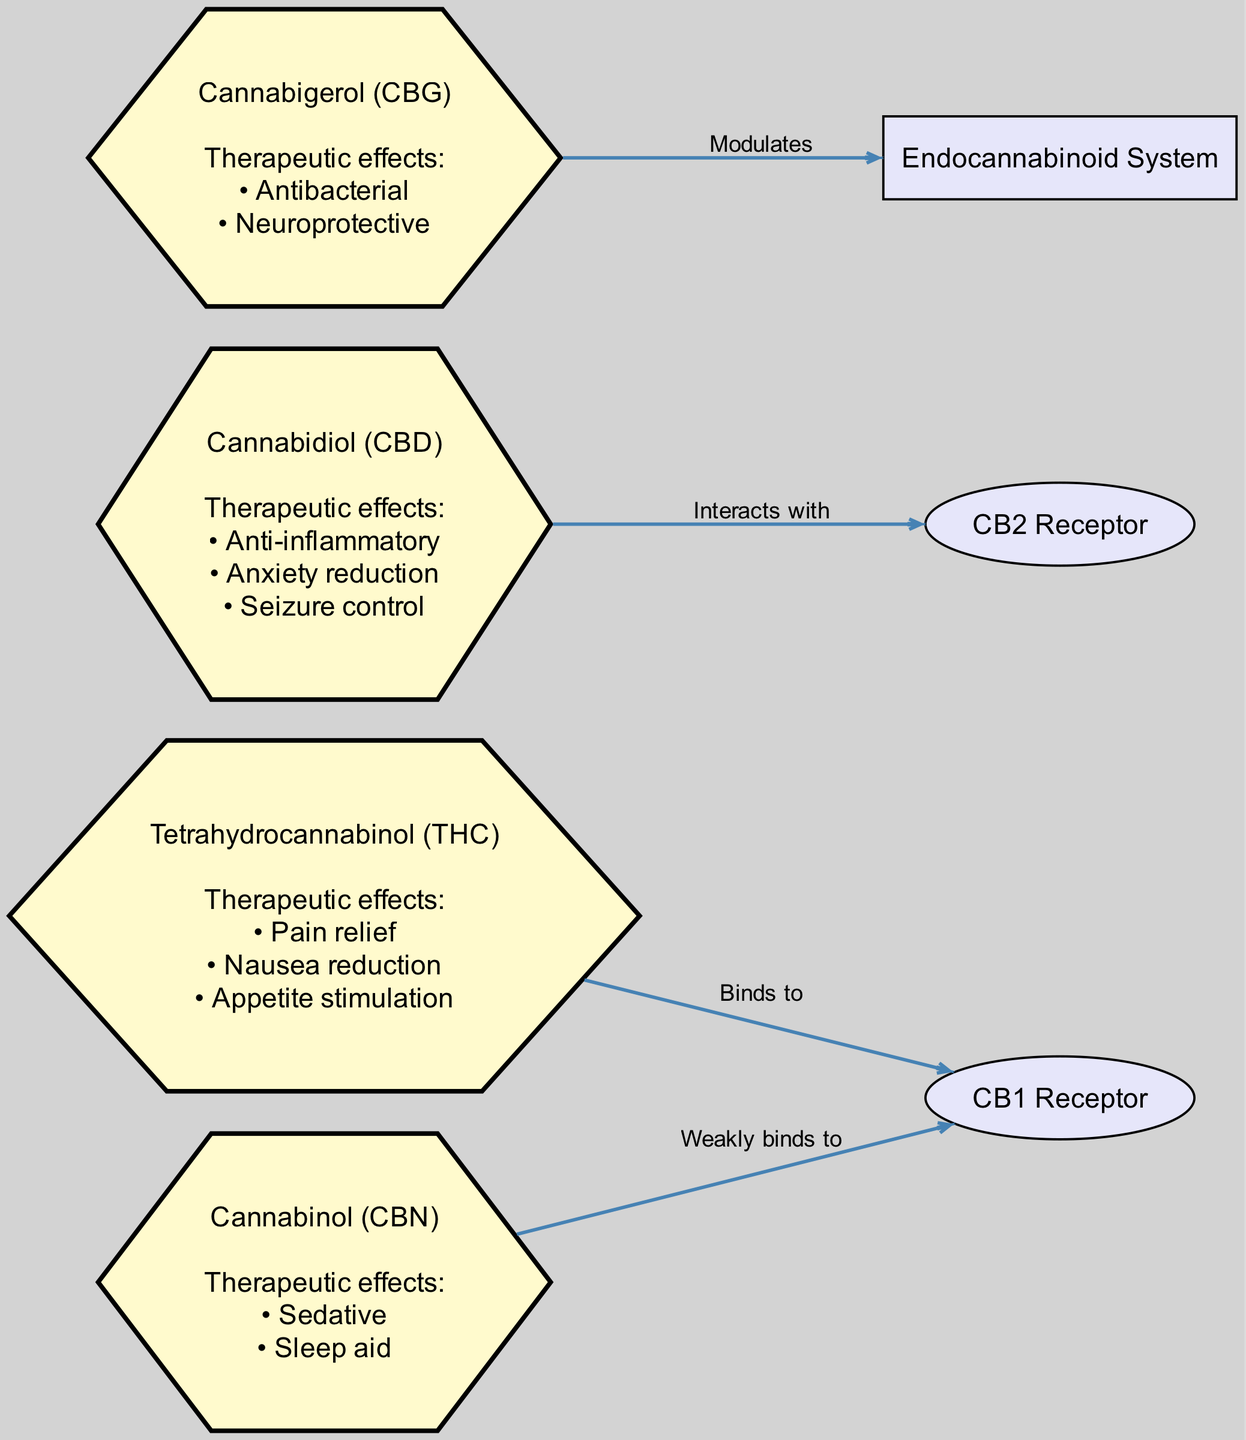What are the therapeutic effects of THC? The diagram indicates the therapeutic effects listed directly under the THC node: Pain relief, Nausea reduction, and Appetite stimulation.
Answer: Pain relief, Nausea reduction, Appetite stimulation How many nodes are there in total? The total number of nodes includes both the cannabinoid nodes (THC, CBD, CBN, CBG) and the additional nodes (CB1 receptor, CB2 receptor, Endocannabinoid system). This totals to 7 nodes.
Answer: 7 Which cannabinoid interacts with the CB2 receptor? According to the diagram, the CBD node is linked to the CB2 receptor, indicating that it interacts with it.
Answer: CBD What therapeutic effect is associated with CBN? The diagram shows that CBN has two therapeutic effects listed, which are Sedative and Sleep aid.
Answer: Sedative, Sleep aid How many edges connect the cannabinoid nodes to the receptors? Counting the edges in the diagram that connect cannabinoid nodes to receptors reveals three connections: THC binds to CB1 receptor, CBD interacts with CB2 receptor, and CBN weakly binds to CB1 receptor.
Answer: 3 Which cannabinoid is primarily associated with pain relief? From the information in the diagram, THC is the cannabinoid linked to pain relief as shown in its therapeutic effects.
Answer: THC What type of receptor does CBG modulate? The diagram specifies that CBG modulates the Endocannabinoid system, indicating its influence rather than binding.
Answer: Endocannabinoid system Is CBN a strong or weak binder to the CB1 receptor? The diagram illustrates that CBN is a weak binder to the CB1 receptor, indicating its lesser affinity in comparison to THC.
Answer: Weak Which cannabinoid has anti-inflammatory properties? Based on the therapeutic effects shown in the diagram, CBD is the cannabinoid noted for its anti-inflammatory properties.
Answer: CBD 